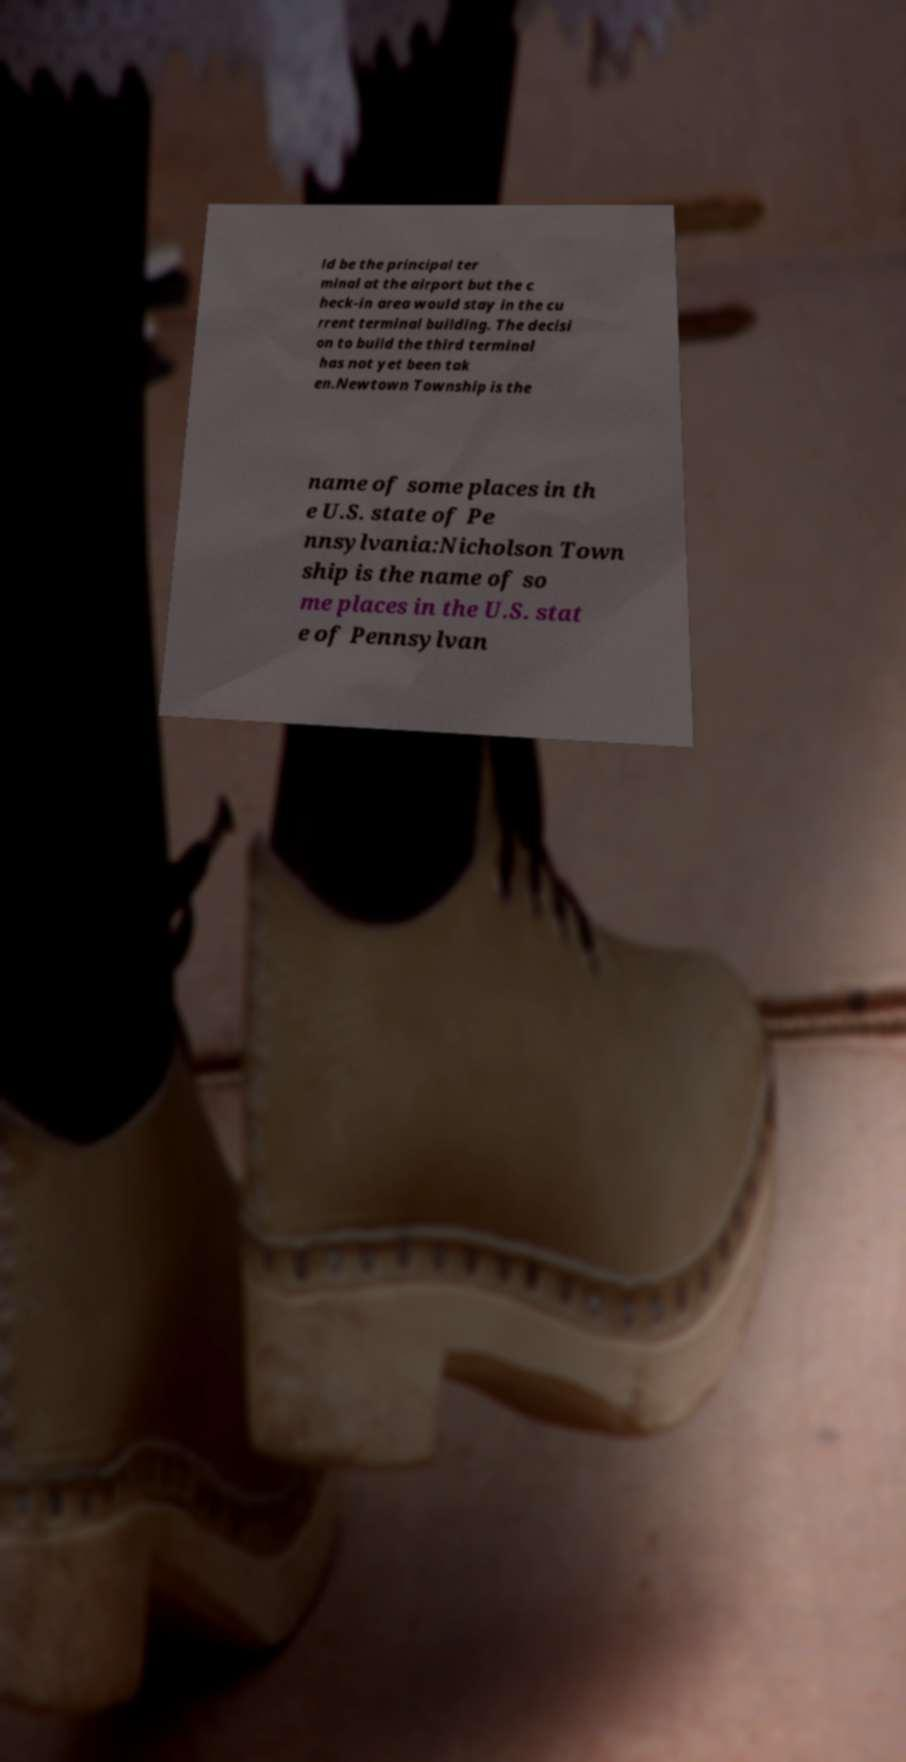Can you read and provide the text displayed in the image?This photo seems to have some interesting text. Can you extract and type it out for me? ld be the principal ter minal at the airport but the c heck-in area would stay in the cu rrent terminal building. The decisi on to build the third terminal has not yet been tak en.Newtown Township is the name of some places in th e U.S. state of Pe nnsylvania:Nicholson Town ship is the name of so me places in the U.S. stat e of Pennsylvan 